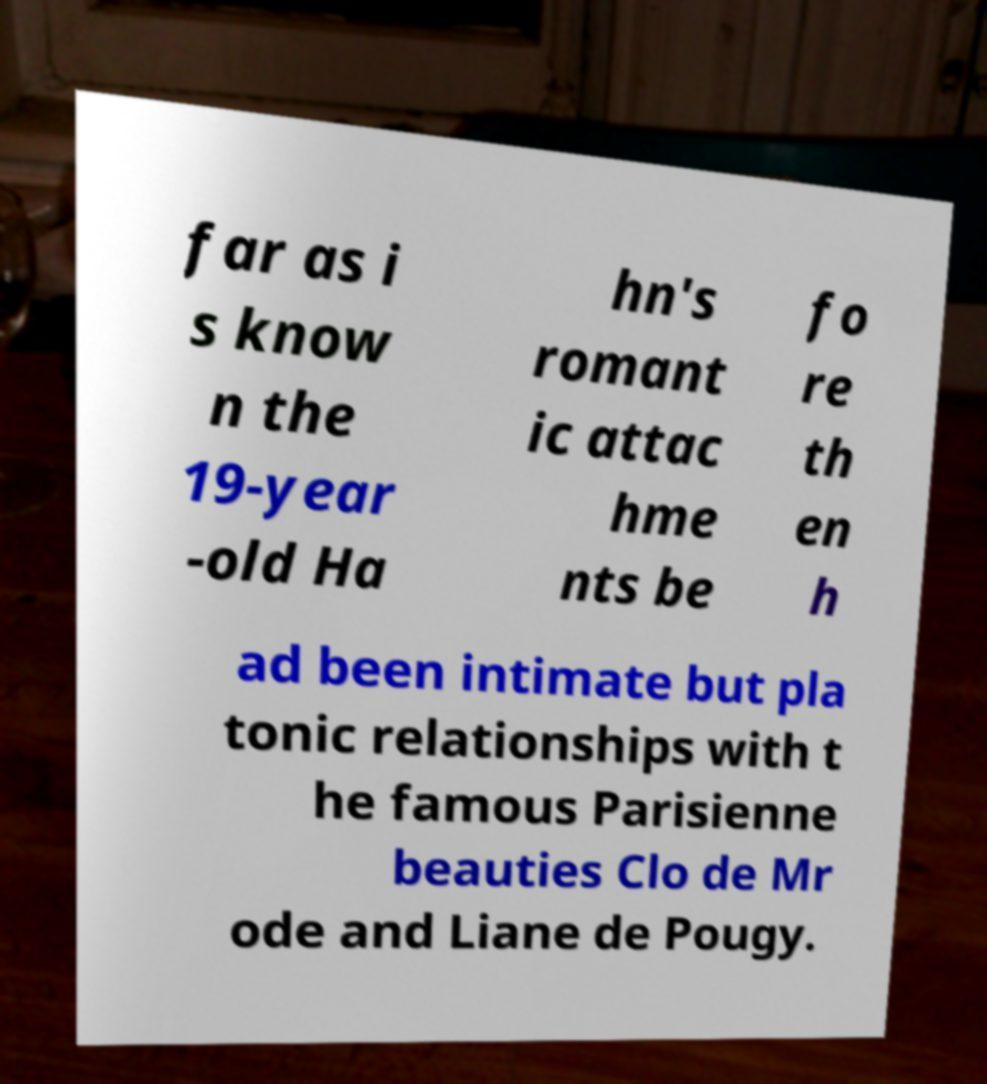Please identify and transcribe the text found in this image. far as i s know n the 19-year -old Ha hn's romant ic attac hme nts be fo re th en h ad been intimate but pla tonic relationships with t he famous Parisienne beauties Clo de Mr ode and Liane de Pougy. 